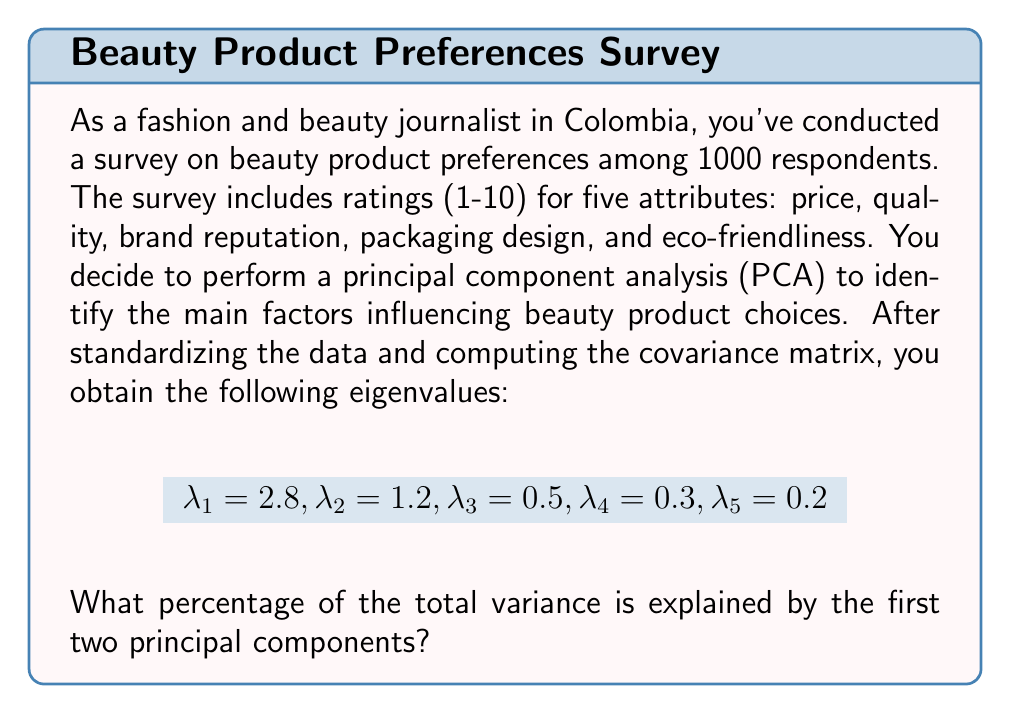Help me with this question. To solve this problem, we need to follow these steps:

1. Understand that in PCA, each eigenvalue represents the amount of variance explained by its corresponding principal component.

2. Calculate the total variance, which is the sum of all eigenvalues:
   $$\text{Total Variance} = \sum_{i=1}^5 \lambda_i = 2.8 + 1.2 + 0.5 + 0.3 + 0.2 = 5$$

3. Calculate the variance explained by the first two principal components:
   $$\text{Variance Explained} = \lambda_1 + \lambda_2 = 2.8 + 1.2 = 4$$

4. Calculate the percentage of variance explained by dividing the variance explained by the first two components by the total variance and multiplying by 100:

   $$\text{Percentage} = \frac{\text{Variance Explained}}{\text{Total Variance}} \times 100\%$$
   
   $$= \frac{4}{5} \times 100\% = 0.8 \times 100\% = 80\%$$

Thus, the first two principal components explain 80% of the total variance in the beauty product preference data.
Answer: 80% 